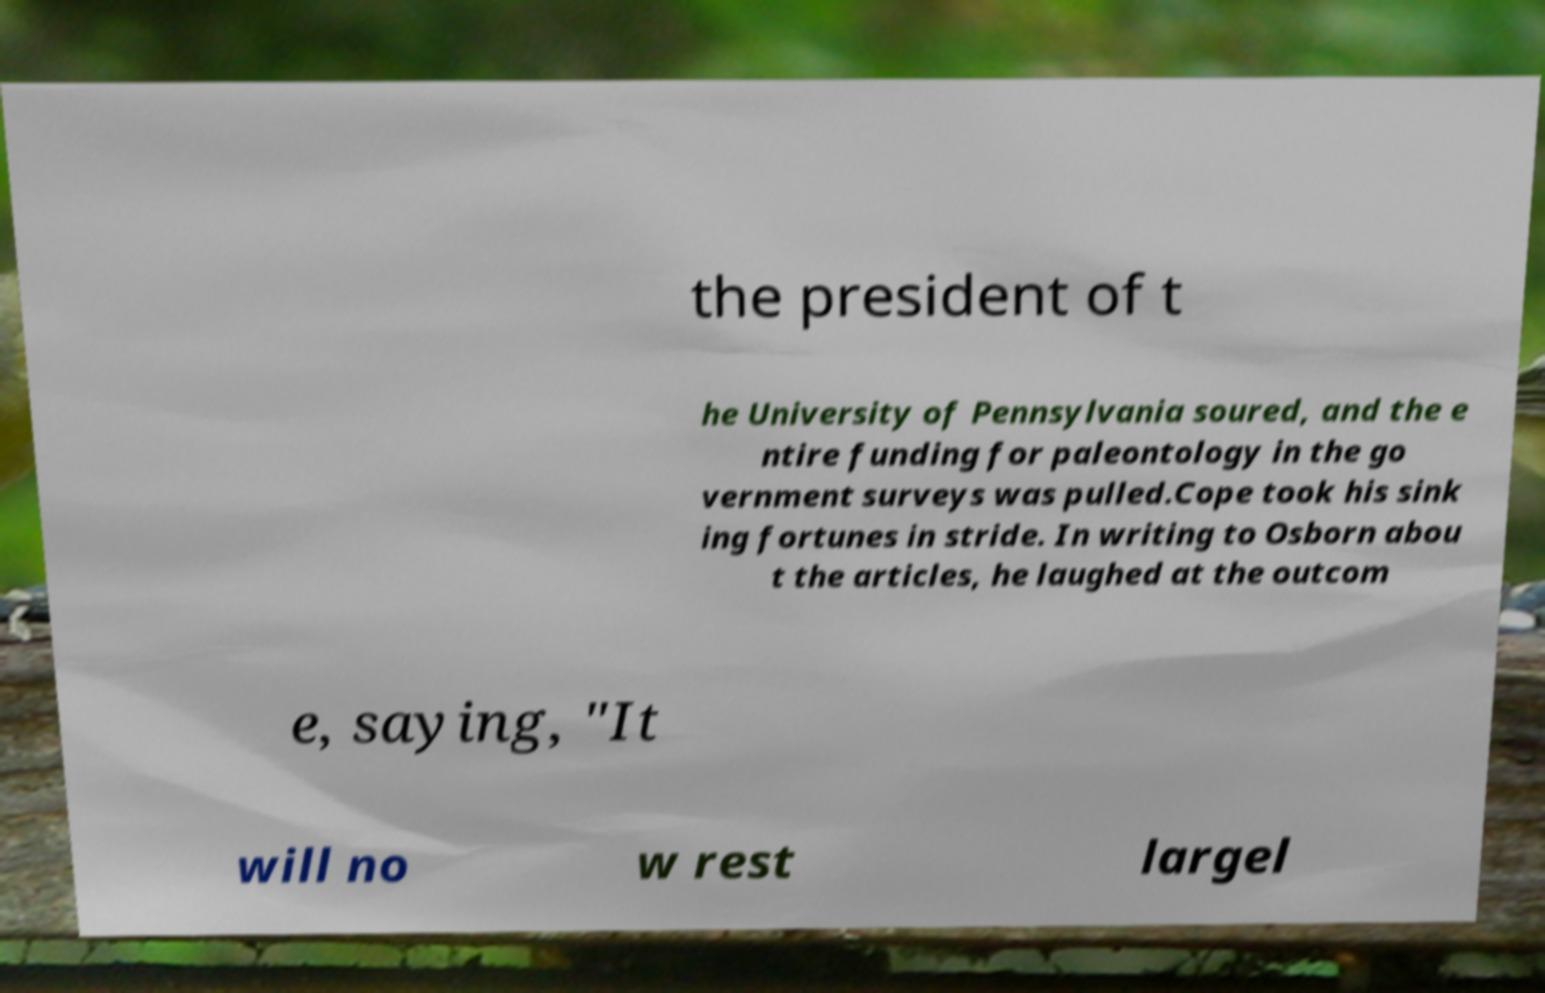Please read and relay the text visible in this image. What does it say? the president of t he University of Pennsylvania soured, and the e ntire funding for paleontology in the go vernment surveys was pulled.Cope took his sink ing fortunes in stride. In writing to Osborn abou t the articles, he laughed at the outcom e, saying, "It will no w rest largel 